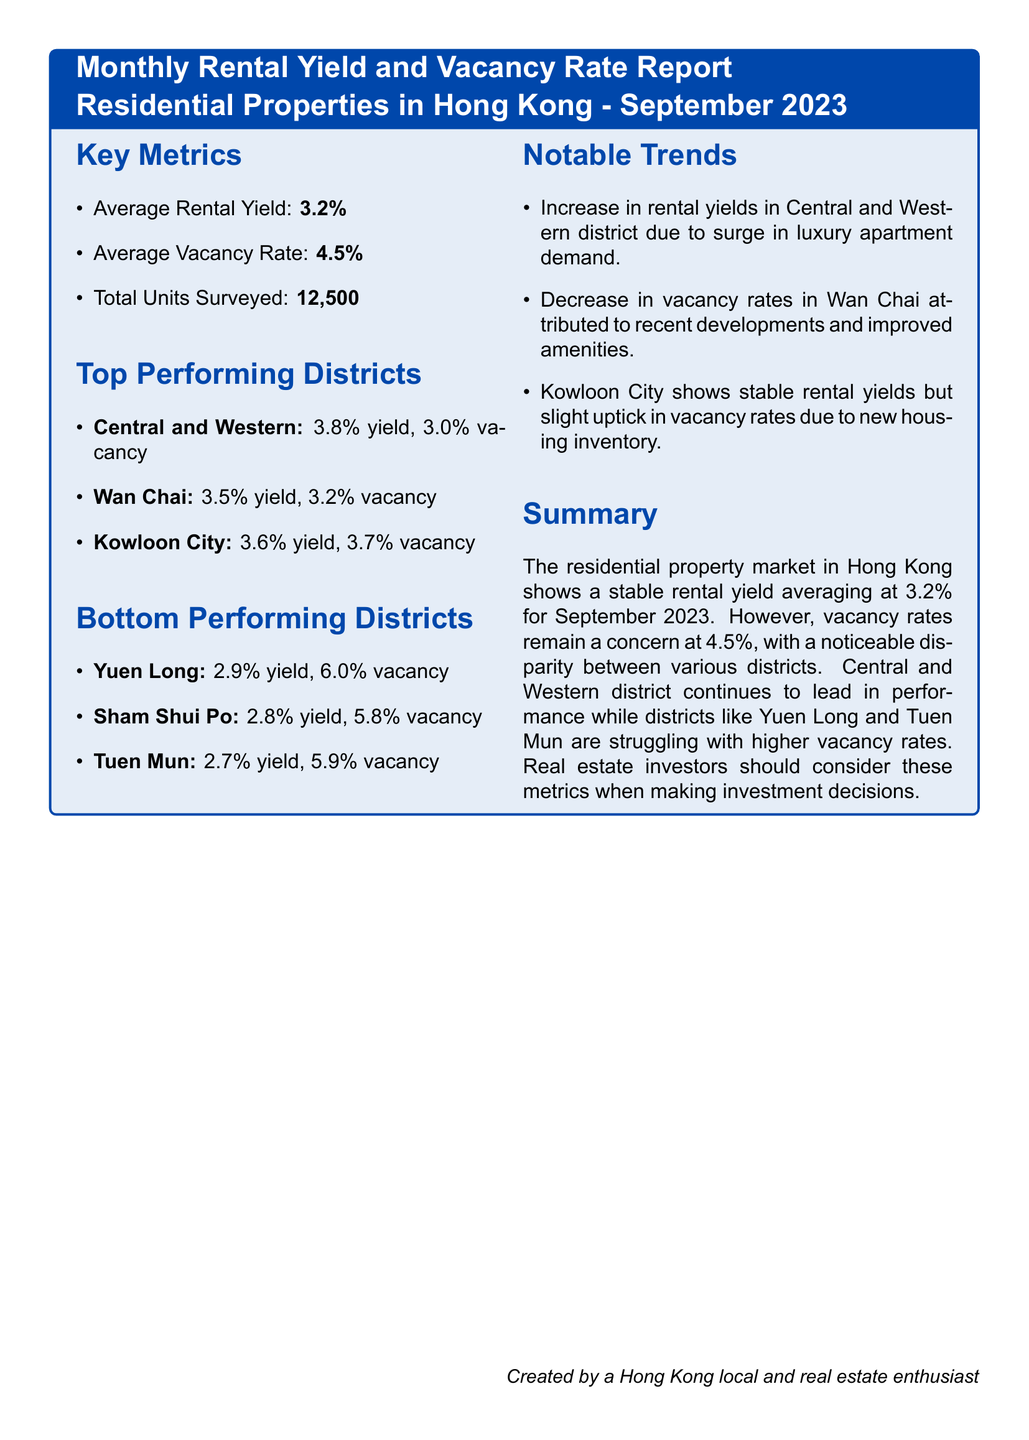What is the average rental yield? The average rental yield is provided in the Key Metrics section of the document.
Answer: 3.2% What is the average vacancy rate? The average vacancy rate is mentioned in the Key Metrics section.
Answer: 4.5% How many total units were surveyed? The number of total units surveyed is listed under Key Metrics.
Answer: 12,500 Which district has the highest rental yield? The highest rental yield is indicated in the Top Performing Districts section.
Answer: Central and Western What is the vacancy rate for Wan Chai? The vacancy rate for Wan Chai is found in the Top Performing Districts section.
Answer: 3.2% Which district is performing the worst in terms of rental yield? The worst-performing district in terms of rental yield can be found in the Bottom Performing Districts section.
Answer: Tuen Mun What notable trend is observed in Kowloon City? The notable trend in Kowloon City is discussed under Notable Trends.
Answer: Stable rental yields but slight uptick in vacancy rates What is the vacancy rate for Yuen Long? The vacancy rate for Yuen Long is provided in the Bottom Performing Districts section.
Answer: 6.0% What is the summary about the residential property market in Hong Kong? The summary section provides an overview of trends in the market.
Answer: Stable rental yield averaging at 3.2% for September 2023 